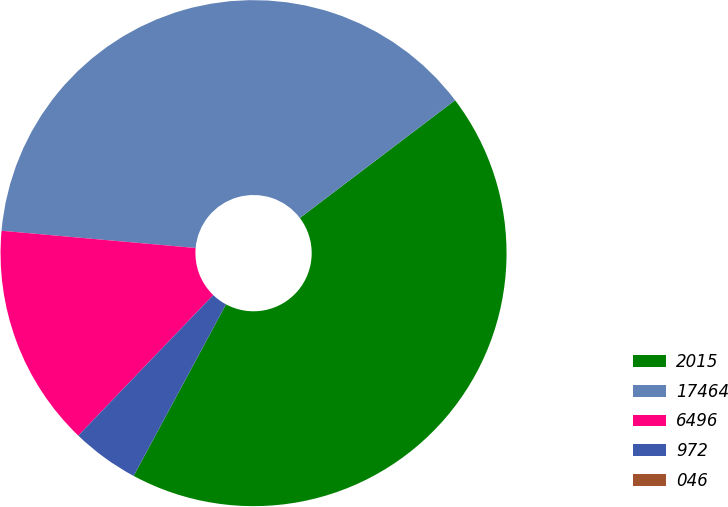Convert chart. <chart><loc_0><loc_0><loc_500><loc_500><pie_chart><fcel>2015<fcel>17464<fcel>6496<fcel>972<fcel>046<nl><fcel>43.19%<fcel>38.26%<fcel>14.23%<fcel>4.32%<fcel>0.0%<nl></chart> 